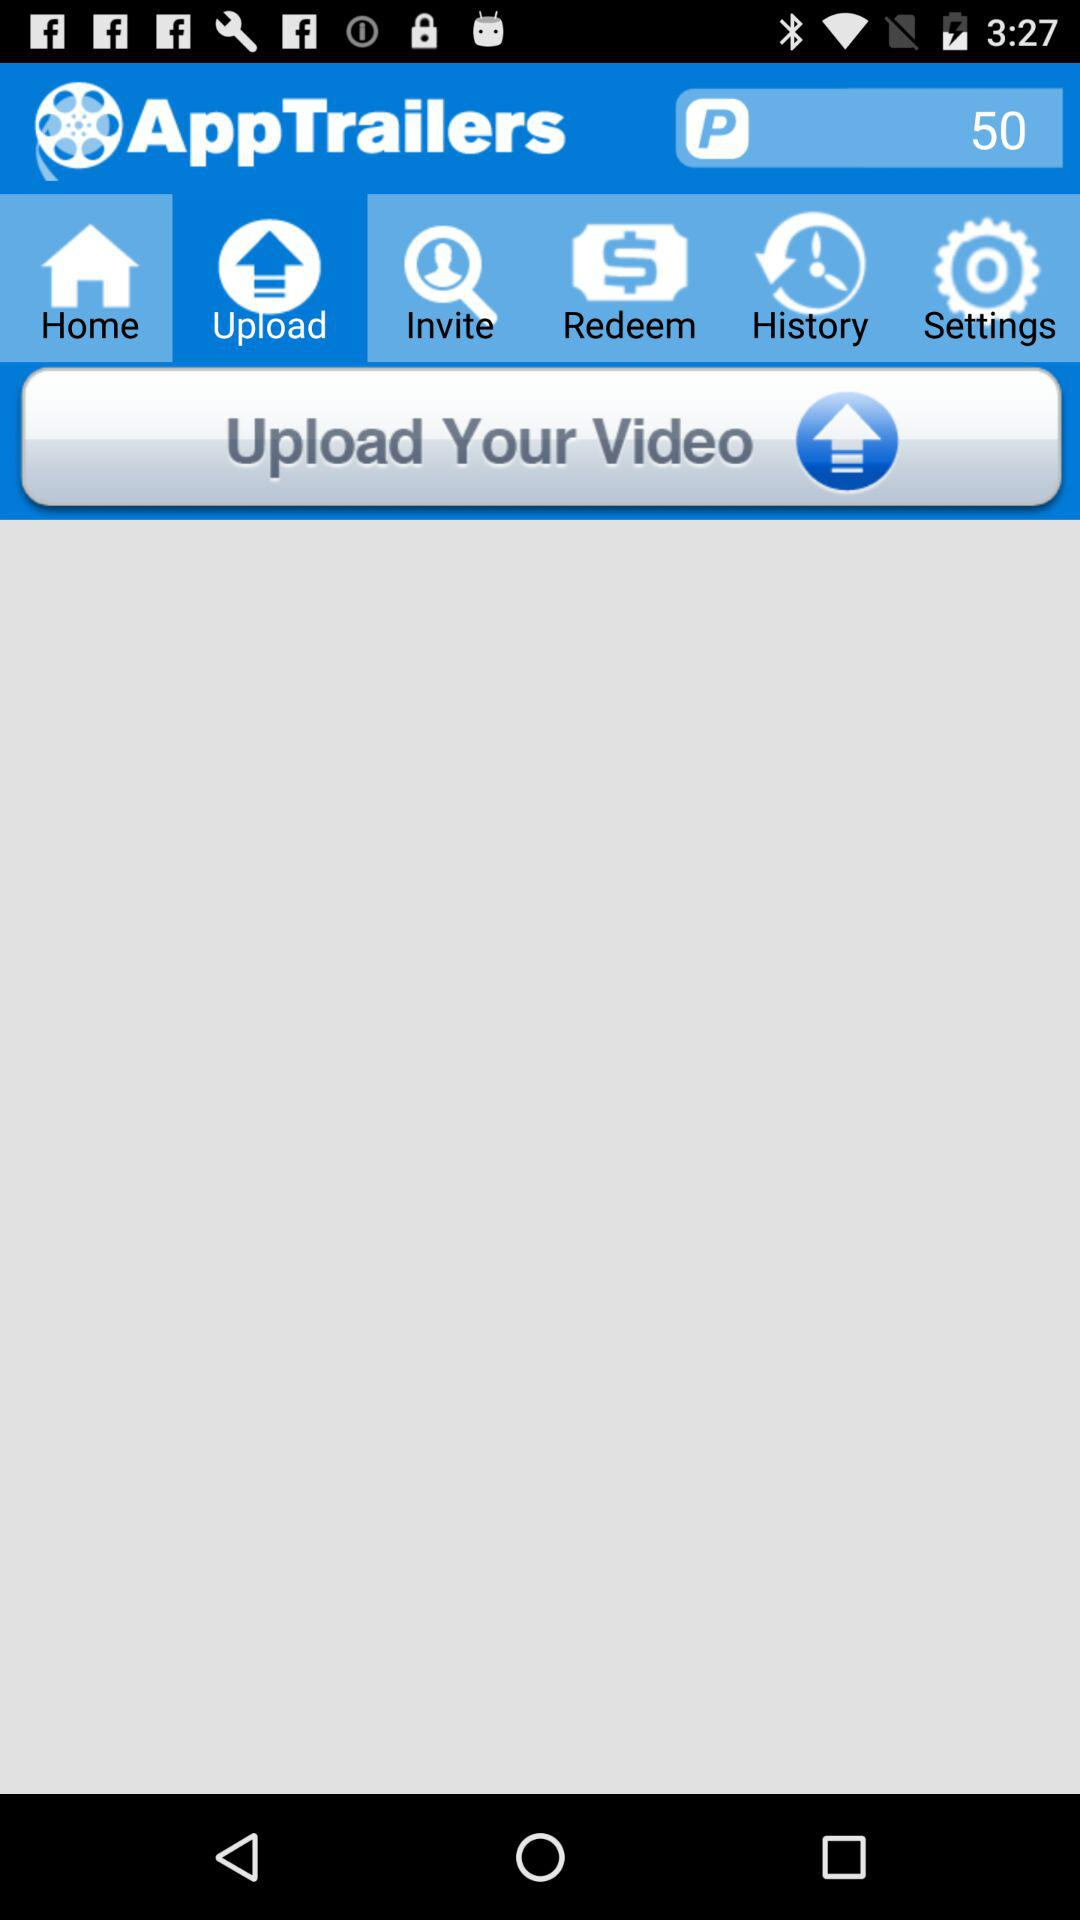Which tab is selected? The selected tab is "Upload". 